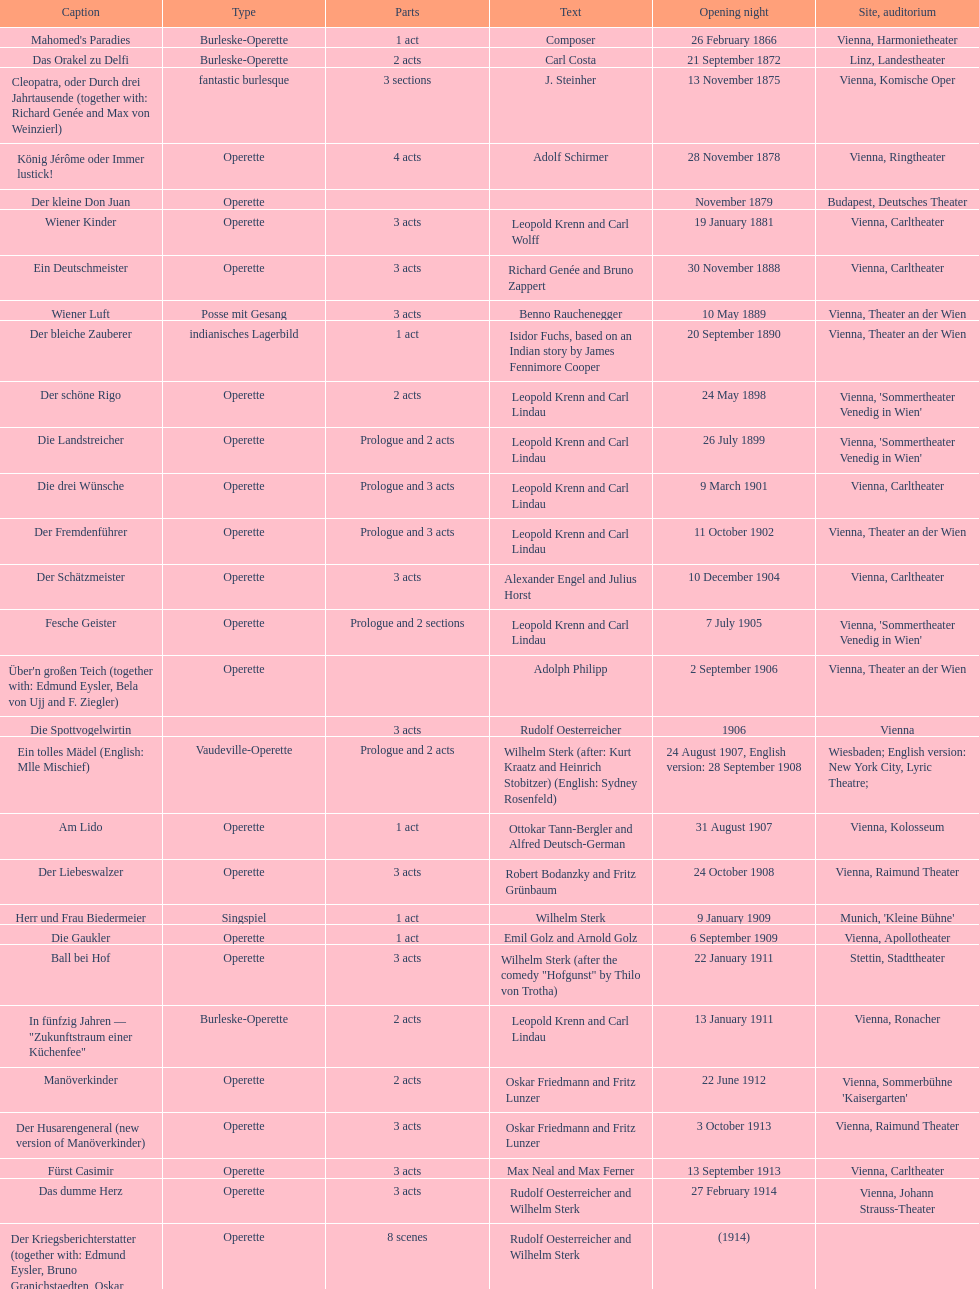In which city did the most operettas premiere? Vienna. 